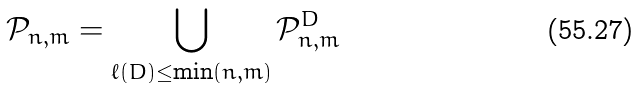<formula> <loc_0><loc_0><loc_500><loc_500>\mathcal { P } _ { n , m } = \bigcup _ { \ell ( D ) \leq \min ( n , m ) } \mathcal { P } _ { n , m } ^ { D }</formula> 